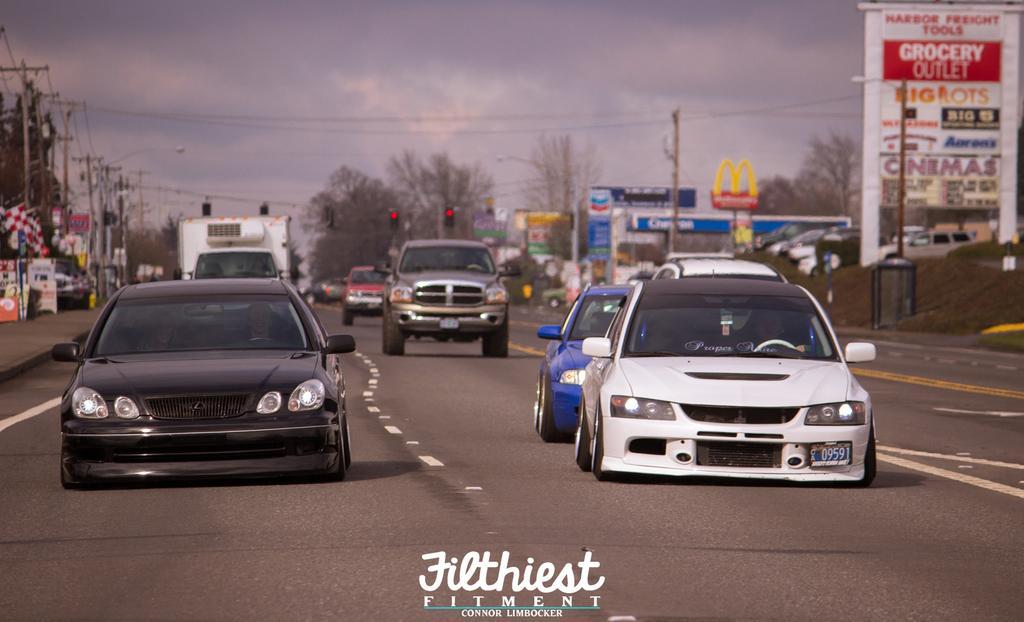<image>
Create a compact narrative representing the image presented. Two Japanese tuner cars on a highway by Filthiest Fitment. 